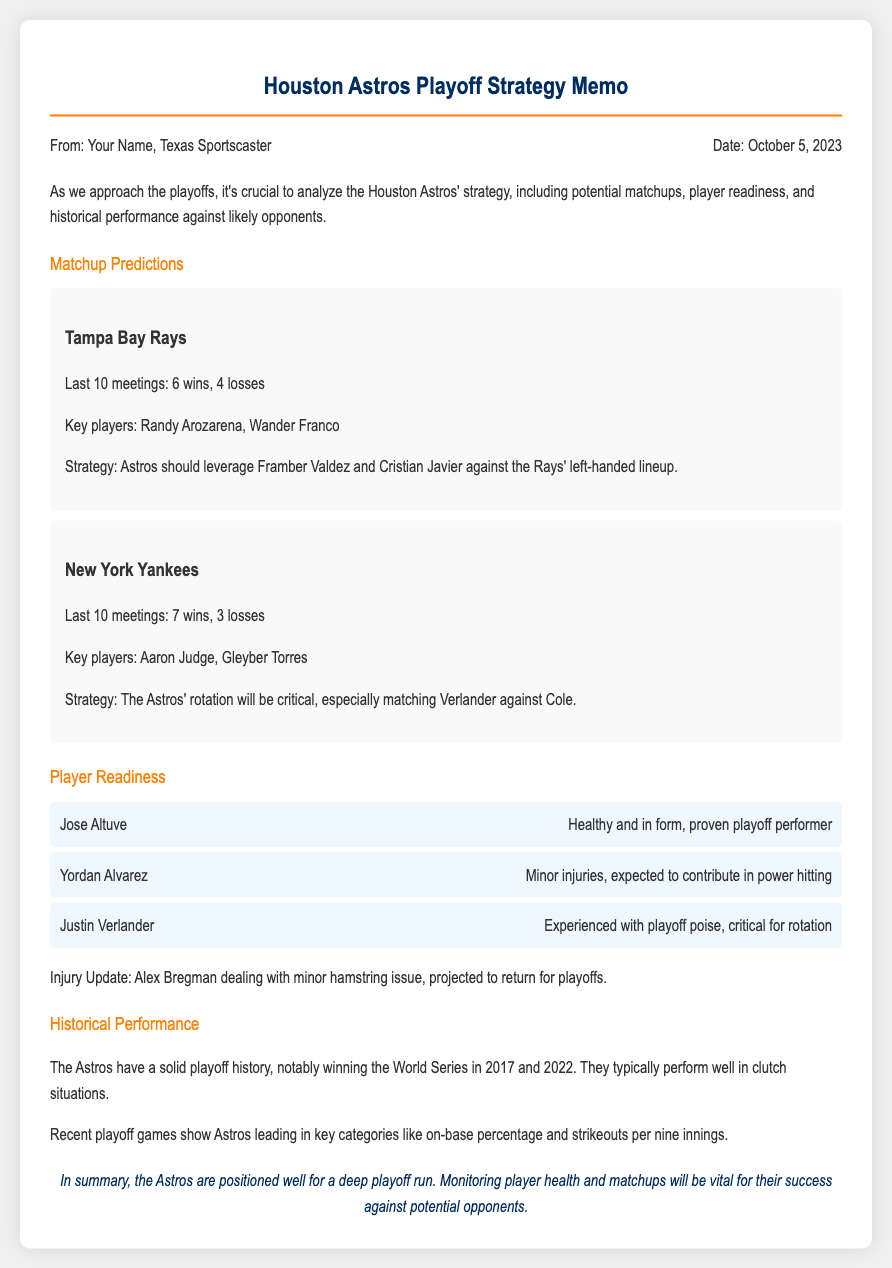what is the date of the memo? The date of the memo is specified in the document, which is October 5, 2023.
Answer: October 5, 2023 who are the key players mentioned for the Tampa Bay Rays? The document specifies two key players for the Tampa Bay Rays: Randy Arozarena and Wander Franco.
Answer: Randy Arozarena, Wander Franco what is Jose Altuve's status? The memo states that Jose Altuve is healthy and in form, making him a proven playoff performer.
Answer: Healthy and in form how many wins do the Astros have in their last 10 meetings with the New York Yankees? The document indicates that the Astros have 7 wins in their last 10 meetings with the New York Yankees.
Answer: 7 wins which player is dealing with a minor injury? The memo mentions that Alex Bregman is dealing with a minor hamstring issue.
Answer: Alex Bregman how many times have the Astros won the World Series according to the historical performance section? The historical performance section notes that the Astros have won the World Series two times, in 2017 and 2022.
Answer: 2 times what specific strategy is recommended against the Rays? The document recommends leveraging Framber Valdez and Cristian Javier against the Rays' left-handed lineup.
Answer: Leverage Framber Valdez and Cristian Javier what aspect of playoff history is highlighted for the Astros? The memo highlights that the Astros typically perform well in clutch situations during playoffs.
Answer: Perform well in clutch situations which two key players are mentioned for the New York Yankees? The key players for the New York Yankees mentioned in the document are Aaron Judge and Gleyber Torres.
Answer: Aaron Judge, Gleyber Torres 